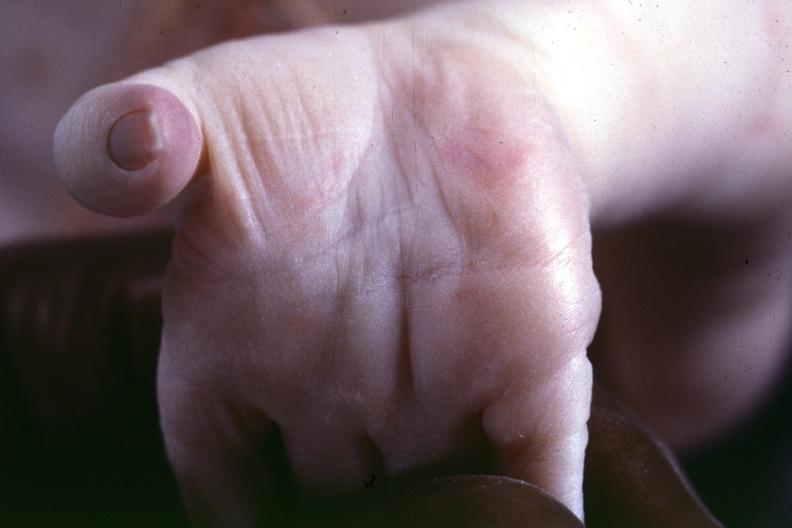s source indicated?
Answer the question using a single word or phrase. Yes 